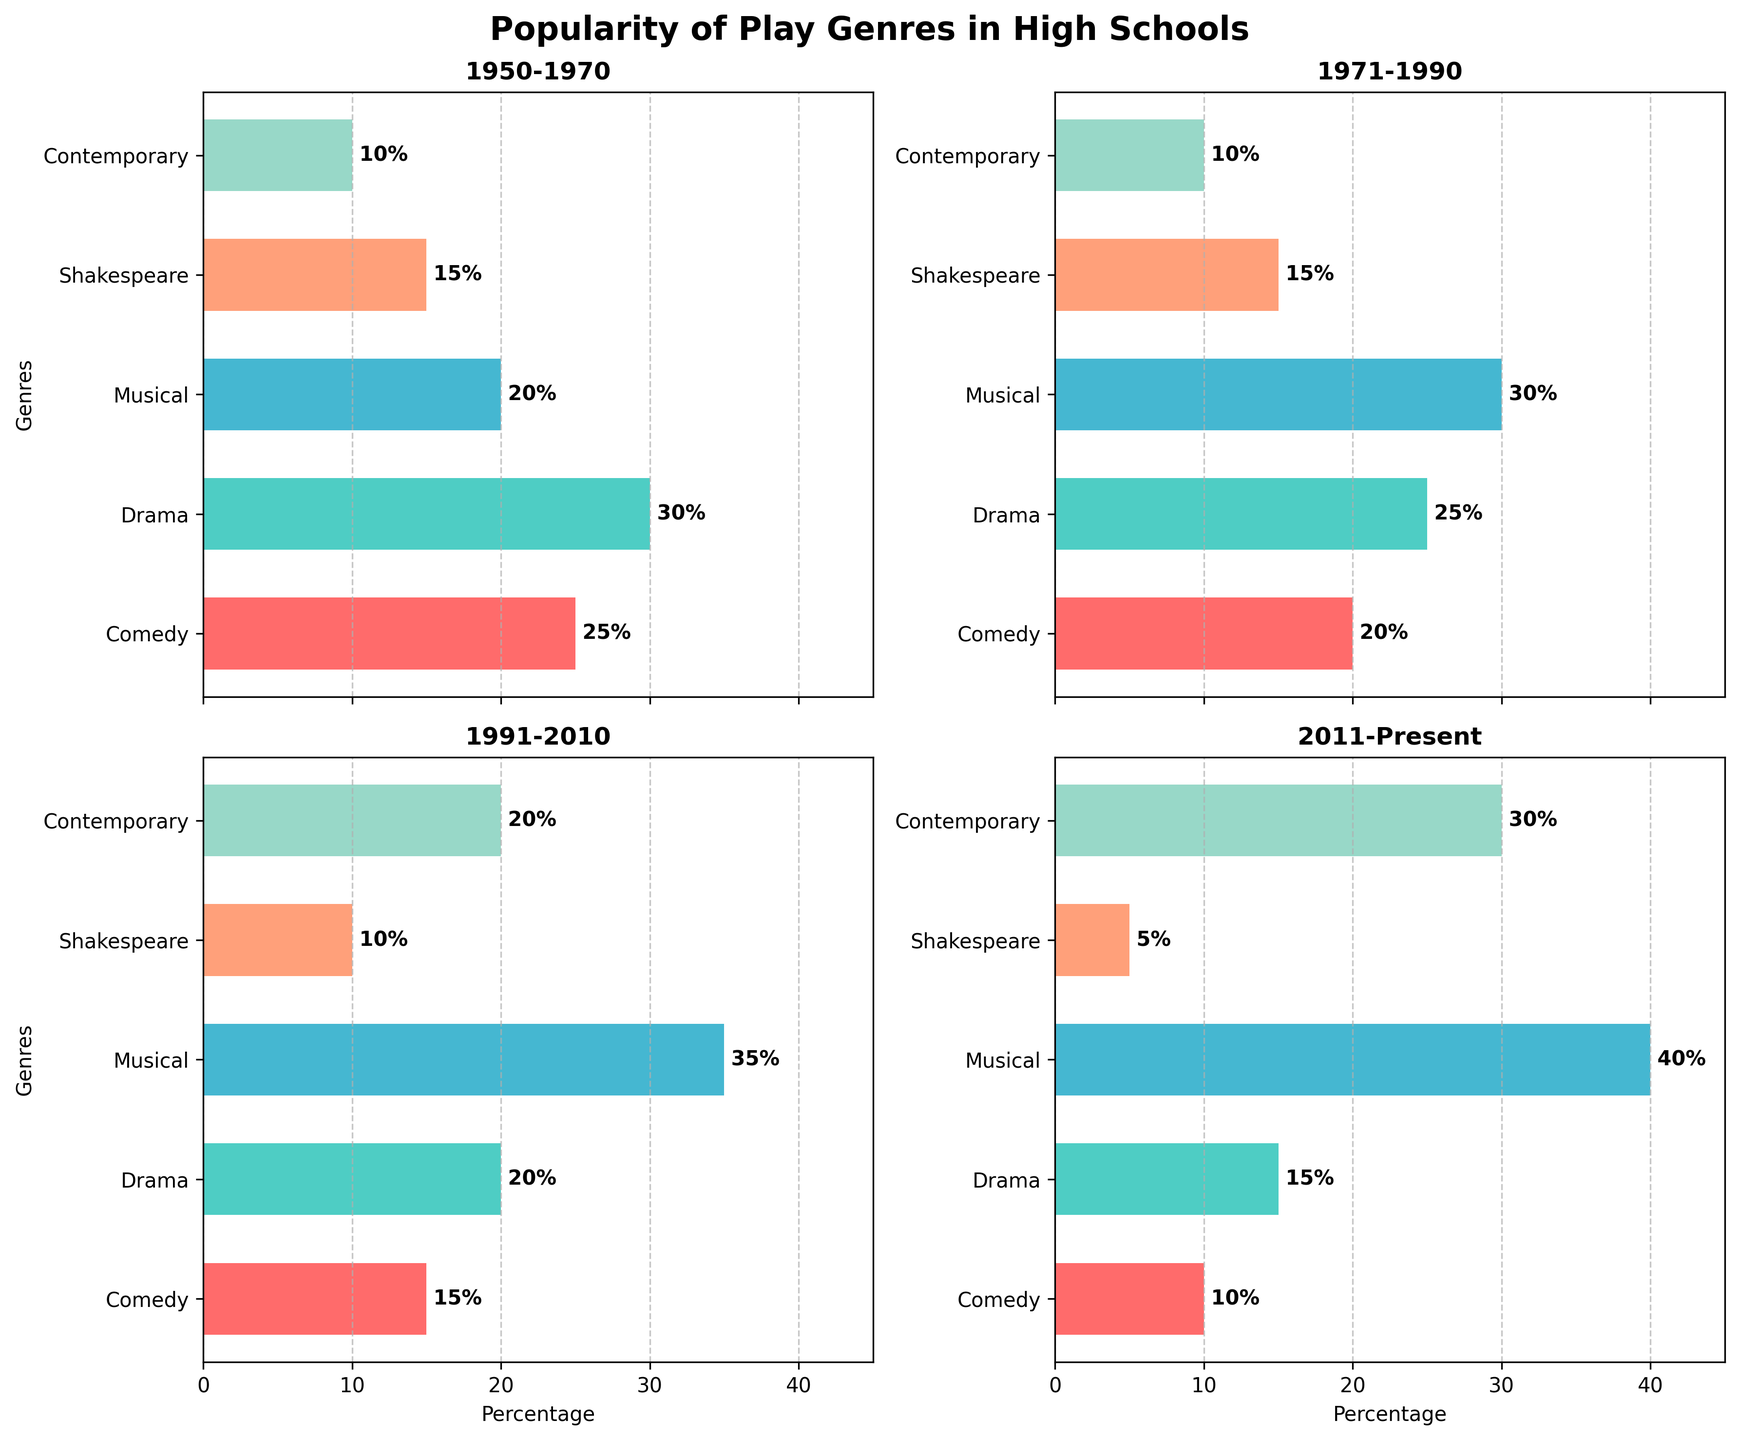what is the time period with the highest percentage of musicals performed? Look at all the subplots and find the percentage of musicals for each time period. The time period 2011-Present has the highest percentage of musicals at 40%.
Answer: 2011-Present Which Time Period Has the Most Even Distribution of Genres? Look for the subplot where the genre percentages are closest to each other. In the subplot for 1950-1970, the percentages are relatively evenly spread compared to other periods.
Answer: 1950-1970 What was the least popular genre during the 1991-2010 period? Look at the subplot for the period 1991-2010 and find the genre with the smallest percentage. Shakespeare was the least popular genre during this period with 10%.
Answer: Shakespeare How does the popularity of contemporary plays change over time? Compare the percentages of contemporary plays in each time period. The percentages are 10% (1950-1970), 10% (1971-1990), 20% (1991-2010), and 30% (2011-Present). The popularity of contemporary plays increases over time.
Answer: Increases over time What is the difference in the popularity of comedy between 1950-1970 and 2011-Present? Compare the comedy percentages in the two subplots. For 1950-1970, comedy is 25%, and for 2011-Present, it's 10%. The difference is 25% - 10% = 15%.
Answer: 15% Which time period has the lowest percentage for Shakespeare plays? Look at each subplot and compare the percentage of Shakespeare plays. The subplot for 2011-Present has the lowest percentage with 5%.
Answer: 2011-Present How did the popularity of dramas evolve from 1950 to the present? Compare the drama percentages across all subplots: 30% (1950-1970), 25% (1971-1990), 20% (1991-2010), and 15% (2011-Present). The popularity of dramas decreases over time.
Answer: Decreases over time Which genre saw the largest increase in popularity from 1950-1970 to 2011-Present? Compare the percentages of each genre in both periods. Contemporary plays increased from 10% in 1950-1970 to 30% in 2011-Present, which is the largest increase of 20%.
Answer: Contemporary Plays How does the distribution of genres in the 1971-1990 period differ from the 1991-2010 period? Compare the genre percentages in the respective subplots. From 1971-1990 to 1991-2010, Comedy decreases by 5%, Drama decreases by 5%, Musical increases by 5%, Shakespeare decreases by 5%, and Contemporary increases by 10%.
Answer: Musicals increase, contemporary increases, others decrease Which genre maintained a steady percentage across all time periods? Look at the percentages for all genres across all subplots. Shakespeare maintains between 5-15% in all periods without significant change.
Answer: Shakespeare 